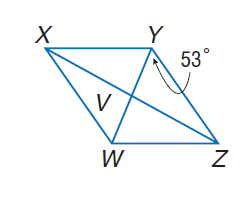Answer the mathemtical geometry problem and directly provide the correct option letter.
Question: Use rhombus X Y Z W with m \angle W Y Z = 53, V W = 3, X V = 2 a - 2, and Z V = \frac { 5 a + 1 } { 4 }. Find X Z.
Choices: A: 2 B: 4 C: 8 D: 16 C 